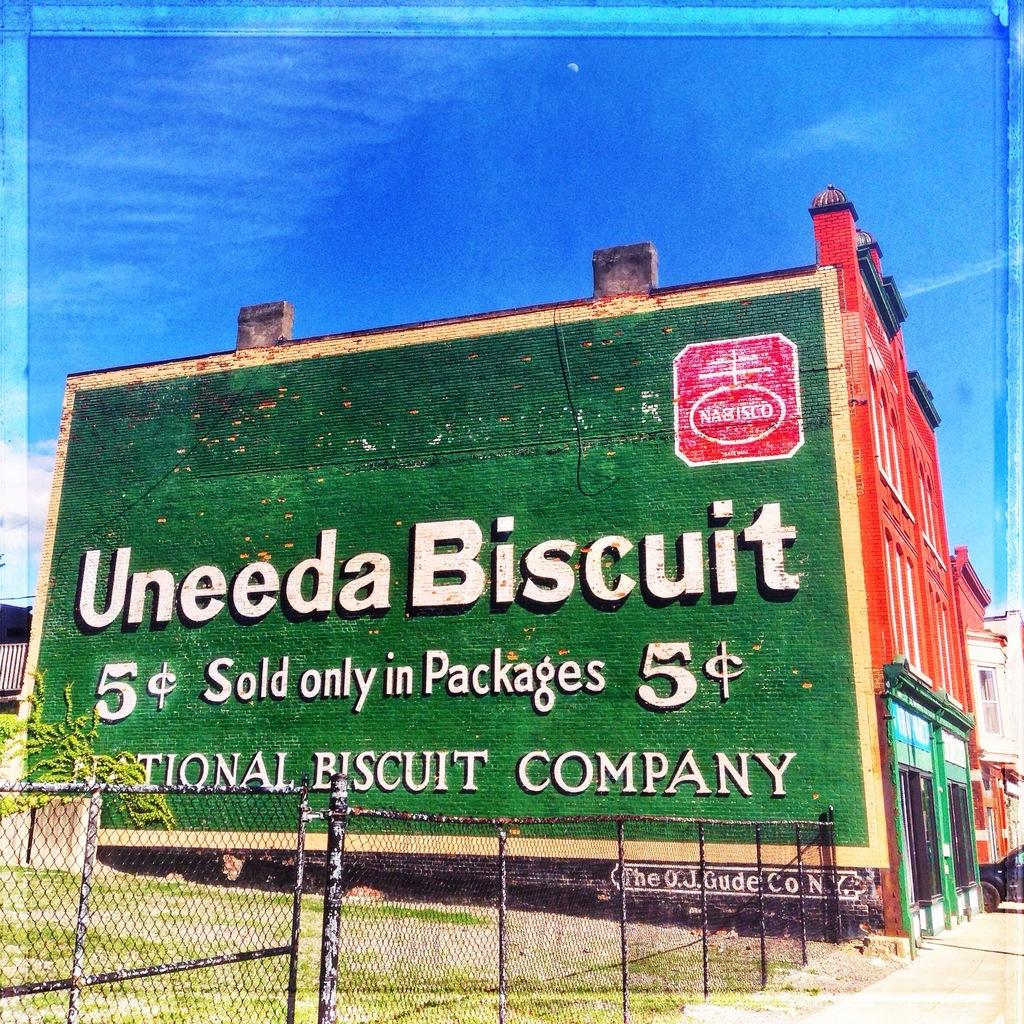<image>
Provide a brief description of the given image. An antique mural on brick for the Uneeda Biscuit from Nabisco. 